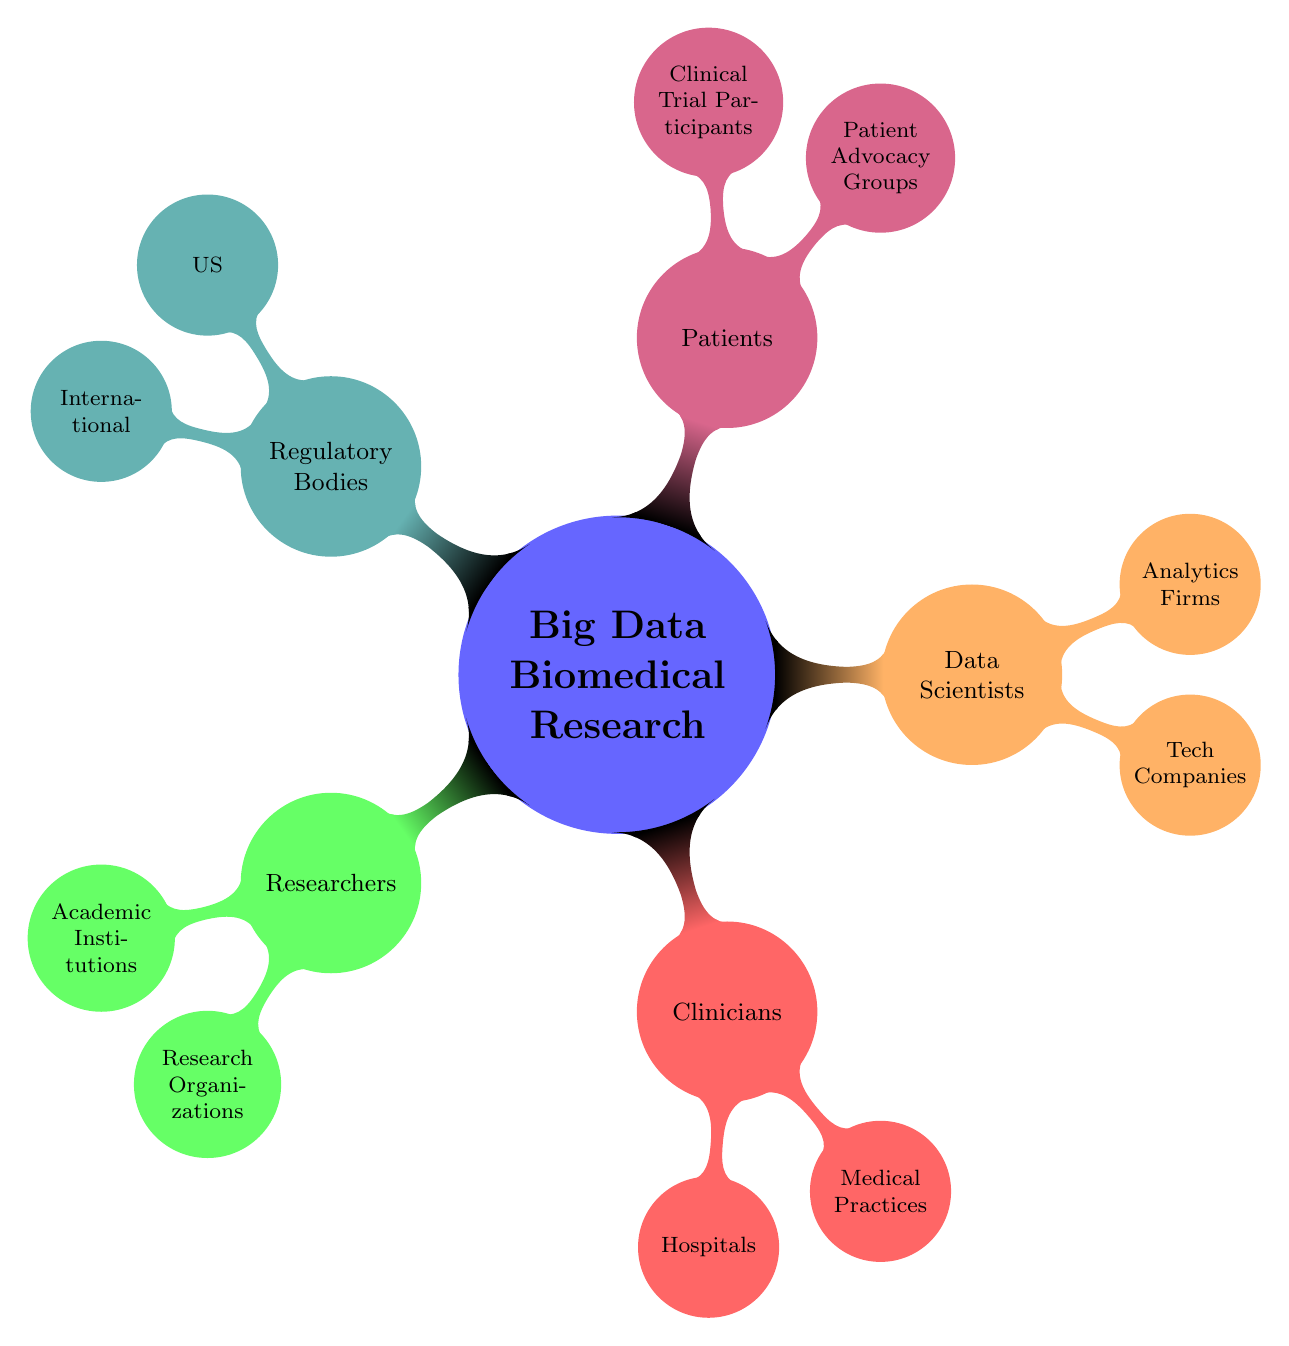What are the two main categories of stakeholders in Big Data Biomedical Research? The diagram categorizes stakeholders into five main groups: Researchers, Clinicians, Data Scientists, Patients, and Regulatory Bodies. Thus, any two of these groups serve as the primary categories.
Answer: Researchers, Clinicians How many types of organizations are listed under Researchers? Under the Researchers category, there are two types of organizations listed: Academic Institutions and Research Organizations. Therefore, the total count of organization types is two.
Answer: 2 Which major stakeholders include "Patient Advocacy Groups"? The term "Patient Advocacy Groups" is found under the Patients category. In the context of this mind map diagram, it highlights the significant role that advocacy groups play in representing patient interests within biomedical research.
Answer: Patients What is one example of a Tech Company involved in Data Science? Within the Data Scientists section, one example given under Tech Companies is Google Health. This answers the inquiry regarding an organization in this specific category.
Answer: Google Health Which regulatory body is listed under the US category? The diagram lists FDA, CDC, and NIH under the Regulatory Bodies section specifically for the US. Any of these answers the question correctly, but one clear example is the FDA.
Answer: FDA What relationships exist between Researchers and Academic Institutions? The relationship depicted in the mind map indicates that Academic Institutions are a subset or type of organization under the broader category of Researchers. This specifically outlines how these two nodes relate in the context of the overall stakeholder framework.
Answer: Academic Institutions How many types of participants are mentioned under Patients? In the Patients category, one type of participant is mentioned: Patient Advocacy Groups. However, the category does note "Clinical Trial Participants" as a subgroup without specific examples, leading to the conclusion that only one type, as labeled, is clearly stated.
Answer: 2 Which international organization is mentioned among Regulatory Bodies? The diagram shows WHO (World Health Organization) listed under the International subgroup of Regulatory Bodies. This directly addresses the inquiry regarding international organizations' involvement in regulatory aspects of biomedical research.
Answer: WHO 